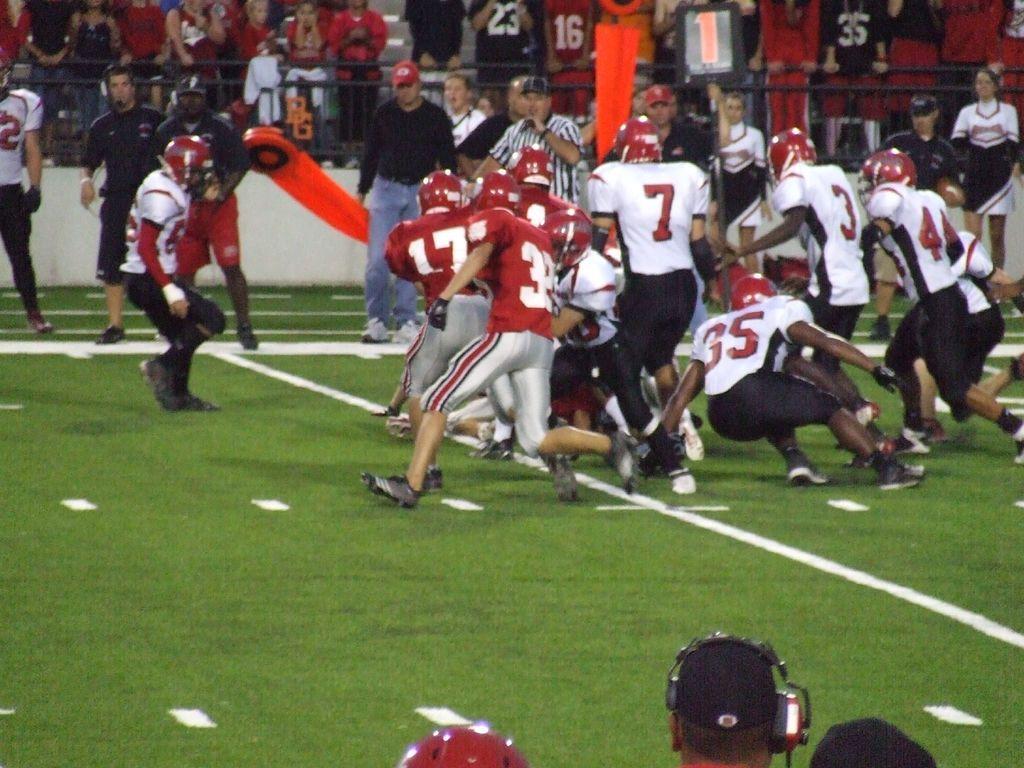How would you summarize this image in a sentence or two? In this image I can see number of persons wearing red and grey colored jersey and few persons wearing white and black colored jersey are standing on the ground. In the background I can see few other persons standing, the black colored railing and number of persons standing and sitting in the stadium. 